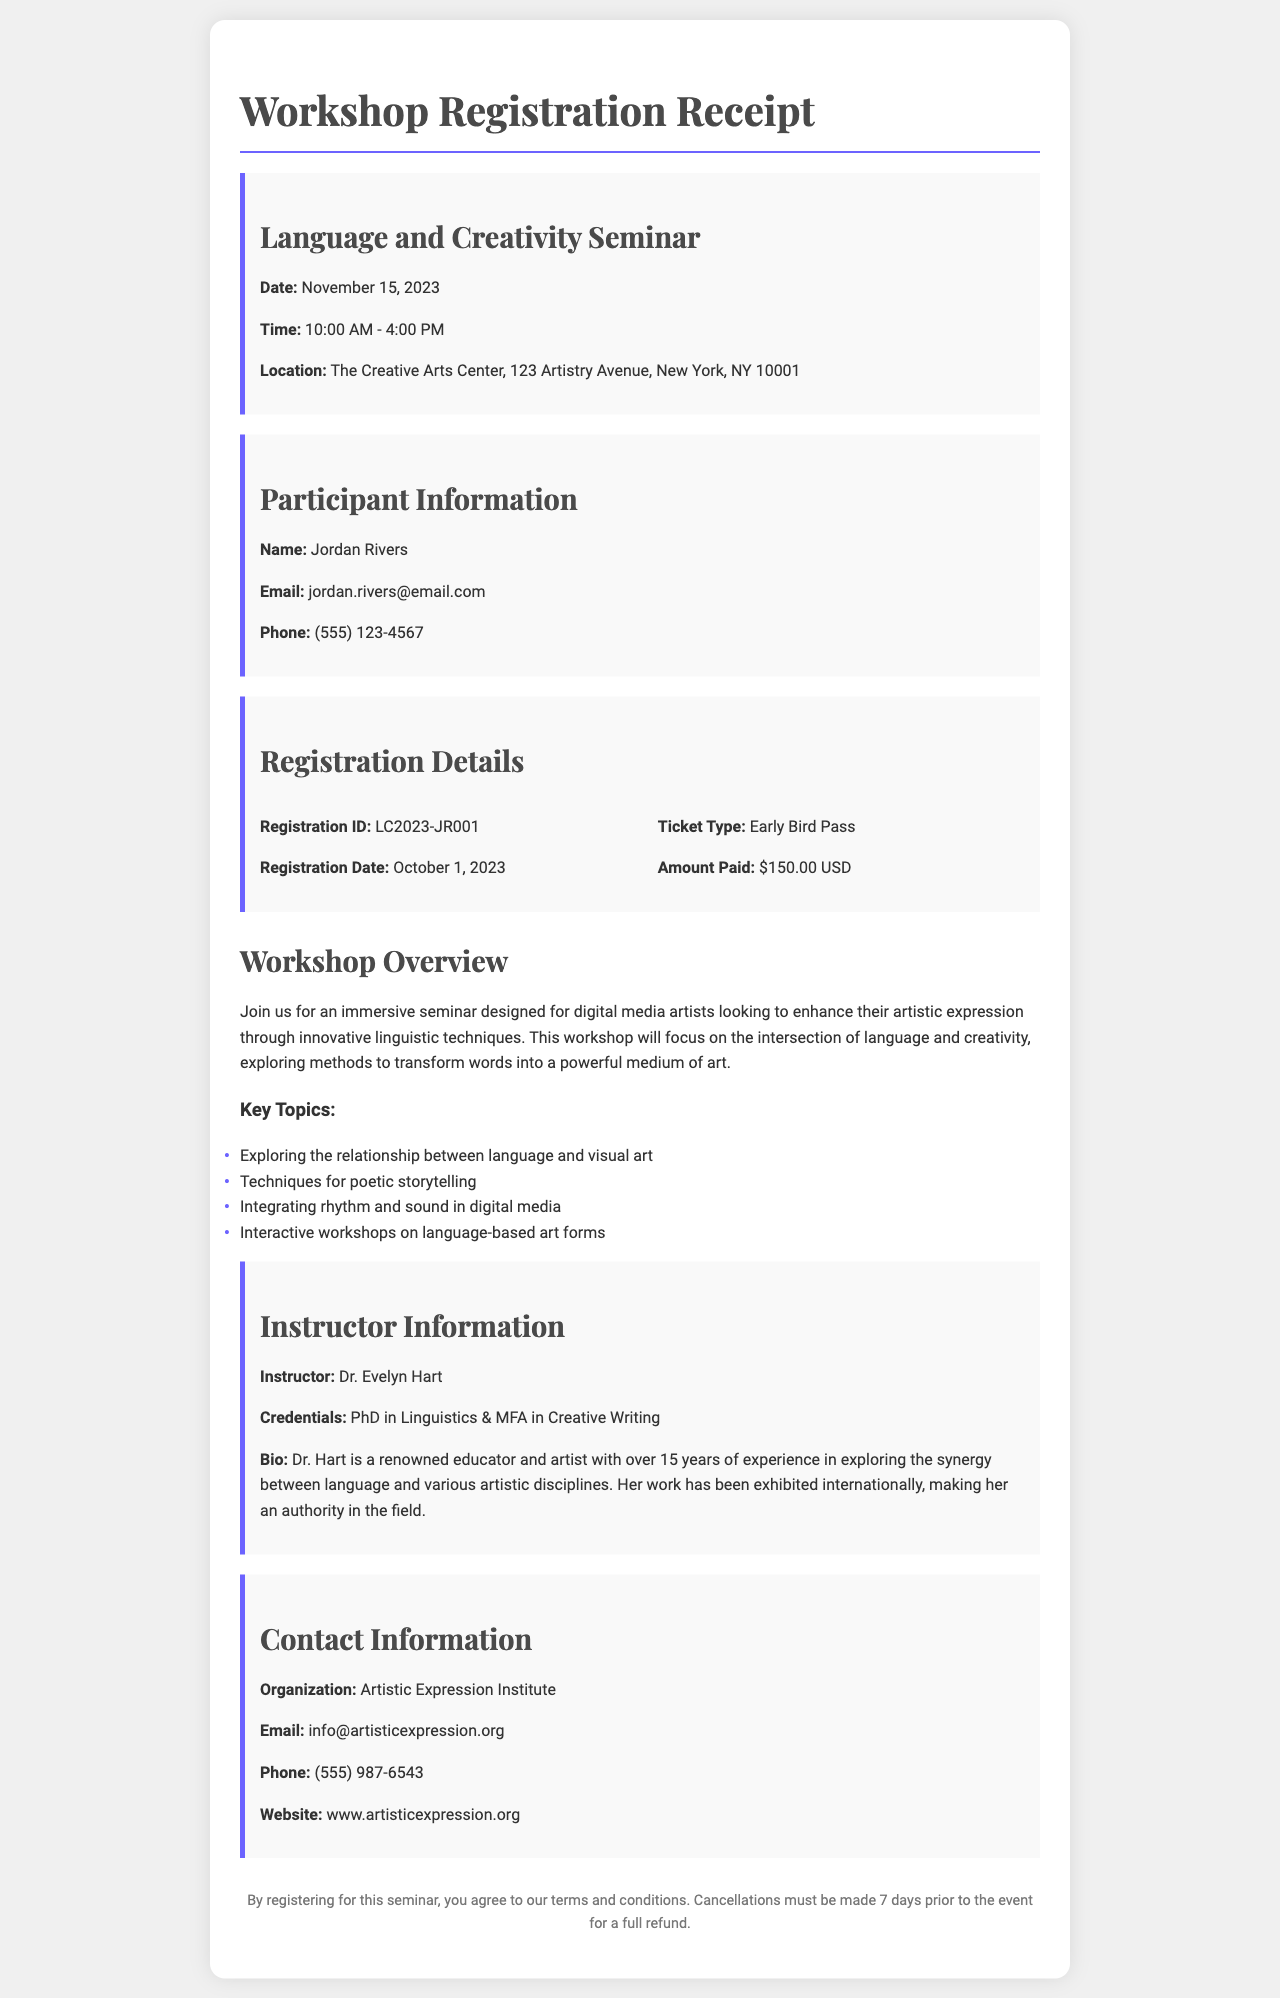What is the name of the seminar? The seminar is titled "Language and Creativity Seminar."
Answer: Language and Creativity Seminar What is the registration ID? The registration ID is listed under Registration Details.
Answer: LC2023-JR001 When is the seminar scheduled? The seminar date is specifically stated in the document.
Answer: November 15, 2023 What time does the seminar start? The document mentions the starting time for the seminar.
Answer: 10:00 AM What amount was paid for the ticket? The amount paid is specified in the registration section of the document.
Answer: $150.00 USD Who is the instructor of the workshop? The instructor's name is provided in the document's instructor information section.
Answer: Dr. Evelyn Hart What is one of the key topics of the seminar? The document lists key topics that will be covered in the seminar.
Answer: Exploring the relationship between language and visual art What is the location of the seminar? The workshop location is clearly stated in the document.
Answer: The Creative Arts Center, 123 Artistry Avenue, New York, NY 10001 How many years of experience does the instructor have? The instructor's experience is mentioned in the bio section of the document.
Answer: Over 15 years 